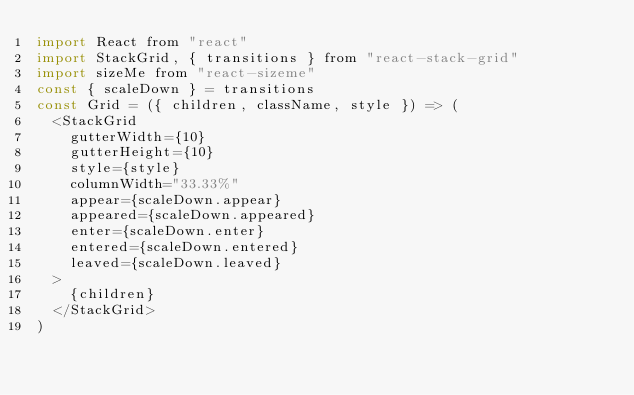<code> <loc_0><loc_0><loc_500><loc_500><_JavaScript_>import React from "react"
import StackGrid, { transitions } from "react-stack-grid"
import sizeMe from "react-sizeme"
const { scaleDown } = transitions
const Grid = ({ children, className, style }) => (
  <StackGrid
    gutterWidth={10}
    gutterHeight={10}
    style={style}
    columnWidth="33.33%"
    appear={scaleDown.appear}
    appeared={scaleDown.appeared}
    enter={scaleDown.enter}
    entered={scaleDown.entered}
    leaved={scaleDown.leaved}
  >
    {children}
  </StackGrid>
)</code> 